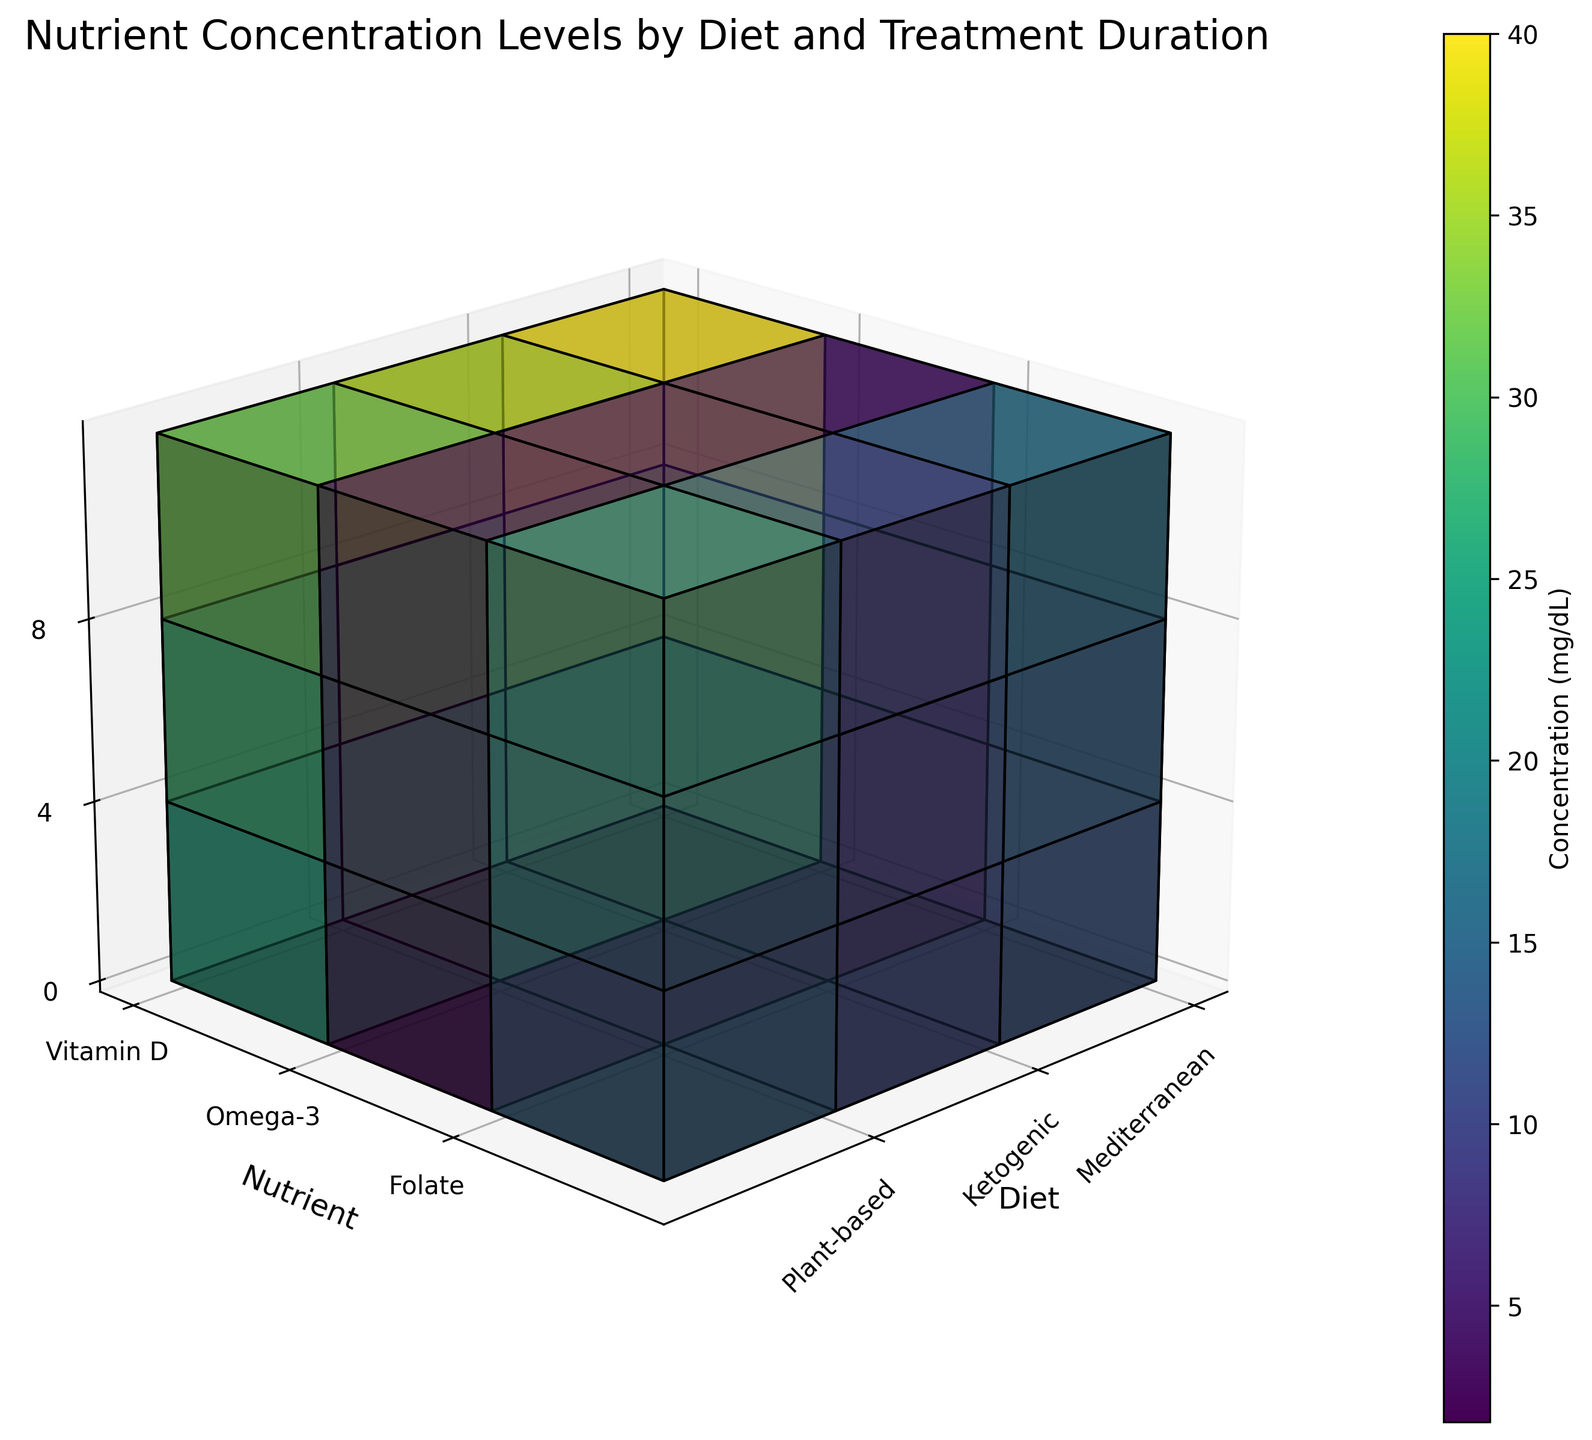What's the title of the figure? The title is usually located at the top of the figure and provides an overview of the data being presented. In this case, the title of the figure is 'Nutrient Concentration Levels by Diet and Treatment Duration'.
Answer: Nutrient Concentration Levels by Diet and Treatment Duration How many types of diets are included in the figure? The figure displays different types of diets along one of its axes, typically the x-axis. The labels on this axis indicate the diets included: 'Mediterranean', 'Ketogenic', and 'Plant-based'.
Answer: 3 Which nutrient shows the highest concentration at week 8 under the Mediterranean diet? Locate the Mediterranean diet on the x-axis, then find week 8 on the z-axis. Identify the nutrient with the highest concentration value from the color or height of the corresponding voxel. In this case, Folate has the highest concentration (16 mg/dL).
Answer: Folate On which week does the Omega-3 concentration reach its maximum value for the Plant-based diet? Locate the Plant-based diet on the x-axis and compare the values of Omega-3 concentration across all weeks. The highest value occurs at week 8 (2.6 mg/dL).
Answer: Week 8 Compare the Vitamin D concentration at week 4 between all three diets. Which diet has the highest concentration? Examine the Vitamin D concentration values for week 4 across all diets. The Mediterranean diet has the highest value (35 mg/dL) compared to Ketogenic (32 mg/dL) and Plant-based (28 mg/dL).
Answer: Mediterranean Which diet shows the lowest overall concentration of Omega-3 across all weeks? Compare the Omega-3 concentration values for all weeks across all diets. The Plant-based diet has the lowest overall values (1.8, 2.2, 2.6 mg/dL).
Answer: Plant-based What is the average concentration of Folate across weeks 0, 4, and 8 for the Ketogenic diet? Locate the Folate concentration values for the Ketogenic diet at weeks 0, 4, and 8. The values are 10, 11, and 12 mg/dL. Compute the average: (10 + 11 + 12) / 3 = 11 mg/dL.
Answer: 11 mg/dL Does the concentration of each nutrient increase or decrease over time for the Mediterranean diet? For each nutrient under the Mediterranean diet, examine the concentration values at weeks 0, 4, and 8. All nutrients (Vitamin D, Omega-3, Folate) show an increase over time.
Answer: Increase 